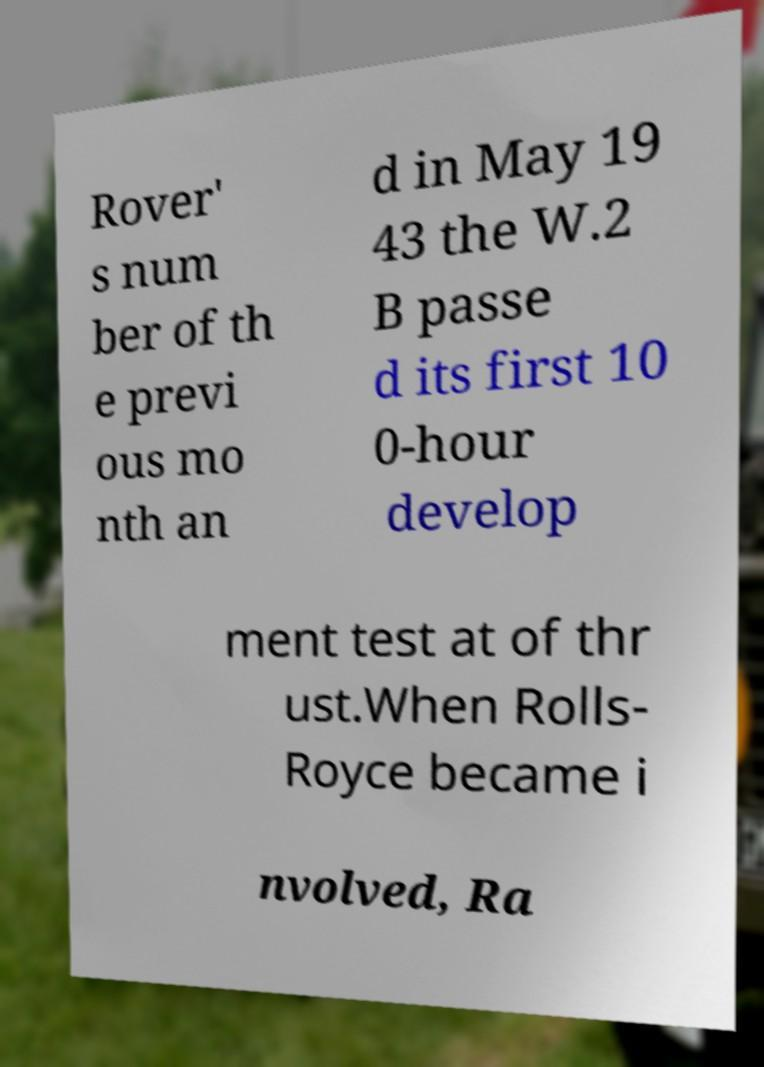I need the written content from this picture converted into text. Can you do that? Rover' s num ber of th e previ ous mo nth an d in May 19 43 the W.2 B passe d its first 10 0-hour develop ment test at of thr ust.When Rolls- Royce became i nvolved, Ra 